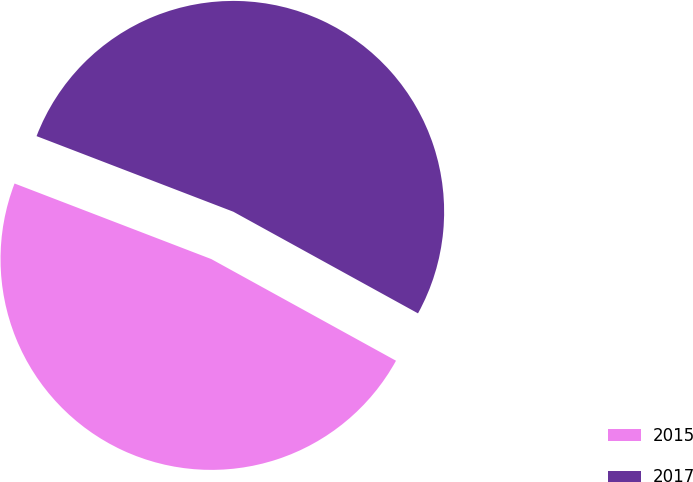<chart> <loc_0><loc_0><loc_500><loc_500><pie_chart><fcel>2015<fcel>2017<nl><fcel>47.83%<fcel>52.17%<nl></chart> 